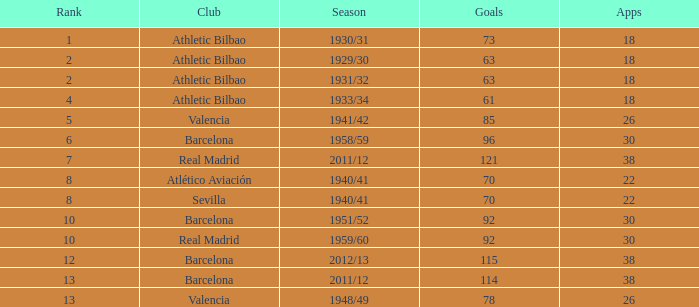What season was Barcelona ranked higher than 12, had more than 96 goals and had more than 26 apps? 2011/12. 